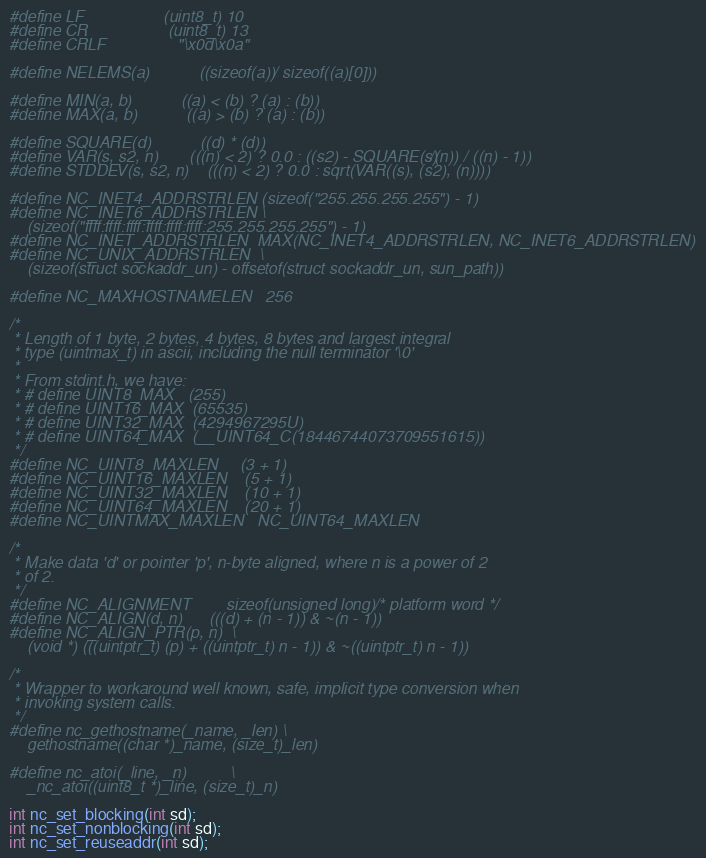<code> <loc_0><loc_0><loc_500><loc_500><_C_>#define LF                  (uint8_t) 10
#define CR                  (uint8_t) 13
#define CRLF                "\x0d\x0a"

#define NELEMS(a)           ((sizeof(a)) / sizeof((a)[0]))

#define MIN(a, b)           ((a) < (b) ? (a) : (b))
#define MAX(a, b)           ((a) > (b) ? (a) : (b))

#define SQUARE(d)           ((d) * (d))
#define VAR(s, s2, n)       (((n) < 2) ? 0.0 : ((s2) - SQUARE(s)/(n)) / ((n) - 1))
#define STDDEV(s, s2, n)    (((n) < 2) ? 0.0 : sqrt(VAR((s), (s2), (n))))

#define NC_INET4_ADDRSTRLEN (sizeof("255.255.255.255") - 1)
#define NC_INET6_ADDRSTRLEN \
    (sizeof("ffff:ffff:ffff:ffff:ffff:ffff:255.255.255.255") - 1)
#define NC_INET_ADDRSTRLEN  MAX(NC_INET4_ADDRSTRLEN, NC_INET6_ADDRSTRLEN)
#define NC_UNIX_ADDRSTRLEN  \
    (sizeof(struct sockaddr_un) - offsetof(struct sockaddr_un, sun_path))

#define NC_MAXHOSTNAMELEN   256

/*
 * Length of 1 byte, 2 bytes, 4 bytes, 8 bytes and largest integral
 * type (uintmax_t) in ascii, including the null terminator '\0'
 *
 * From stdint.h, we have:
 * # define UINT8_MAX	(255)
 * # define UINT16_MAX	(65535)
 * # define UINT32_MAX	(4294967295U)
 * # define UINT64_MAX	(__UINT64_C(18446744073709551615))
 */
#define NC_UINT8_MAXLEN     (3 + 1)
#define NC_UINT16_MAXLEN    (5 + 1)
#define NC_UINT32_MAXLEN    (10 + 1)
#define NC_UINT64_MAXLEN    (20 + 1)
#define NC_UINTMAX_MAXLEN   NC_UINT64_MAXLEN

/*
 * Make data 'd' or pointer 'p', n-byte aligned, where n is a power of 2
 * of 2.
 */
#define NC_ALIGNMENT        sizeof(unsigned long) /* platform word */
#define NC_ALIGN(d, n)      (((d) + (n - 1)) & ~(n - 1))
#define NC_ALIGN_PTR(p, n)  \
    (void *) (((uintptr_t) (p) + ((uintptr_t) n - 1)) & ~((uintptr_t) n - 1))

/*
 * Wrapper to workaround well known, safe, implicit type conversion when
 * invoking system calls.
 */
#define nc_gethostname(_name, _len) \
    gethostname((char *)_name, (size_t)_len)

#define nc_atoi(_line, _n)          \
    _nc_atoi((uint8_t *)_line, (size_t)_n)

int nc_set_blocking(int sd);
int nc_set_nonblocking(int sd);
int nc_set_reuseaddr(int sd);</code> 